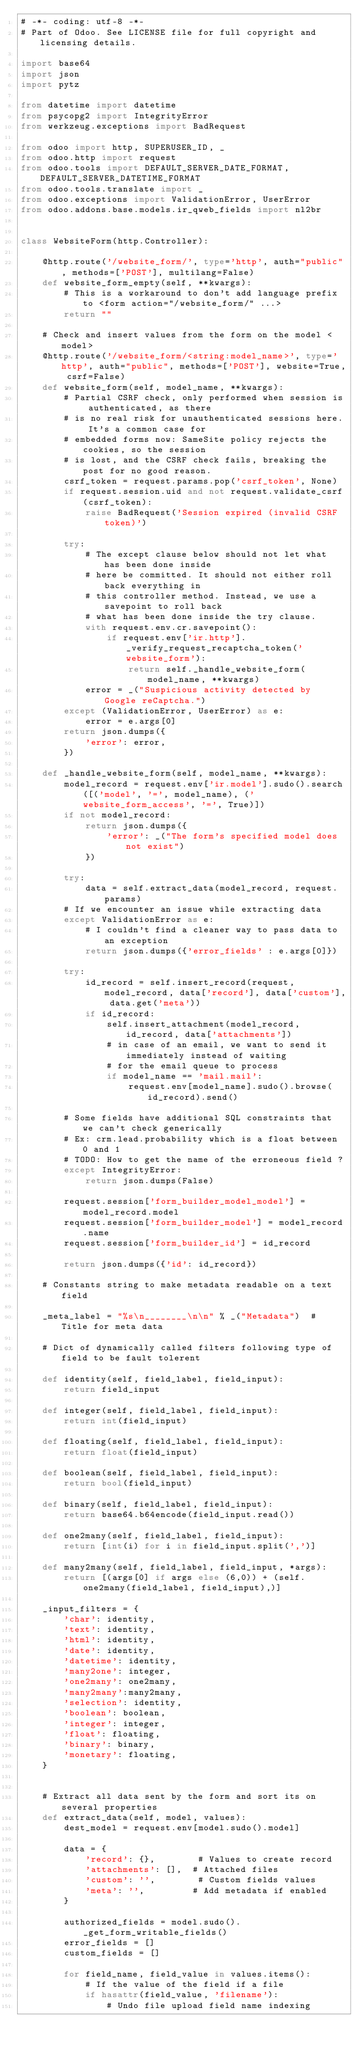<code> <loc_0><loc_0><loc_500><loc_500><_Python_># -*- coding: utf-8 -*-
# Part of Odoo. See LICENSE file for full copyright and licensing details.

import base64
import json
import pytz

from datetime import datetime
from psycopg2 import IntegrityError
from werkzeug.exceptions import BadRequest

from odoo import http, SUPERUSER_ID, _
from odoo.http import request
from odoo.tools import DEFAULT_SERVER_DATE_FORMAT, DEFAULT_SERVER_DATETIME_FORMAT
from odoo.tools.translate import _
from odoo.exceptions import ValidationError, UserError
from odoo.addons.base.models.ir_qweb_fields import nl2br


class WebsiteForm(http.Controller):

    @http.route('/website_form/', type='http', auth="public", methods=['POST'], multilang=False)
    def website_form_empty(self, **kwargs):
        # This is a workaround to don't add language prefix to <form action="/website_form/" ...>
        return ""

    # Check and insert values from the form on the model <model>
    @http.route('/website_form/<string:model_name>', type='http', auth="public", methods=['POST'], website=True, csrf=False)
    def website_form(self, model_name, **kwargs):
        # Partial CSRF check, only performed when session is authenticated, as there
        # is no real risk for unauthenticated sessions here. It's a common case for
        # embedded forms now: SameSite policy rejects the cookies, so the session
        # is lost, and the CSRF check fails, breaking the post for no good reason.
        csrf_token = request.params.pop('csrf_token', None)
        if request.session.uid and not request.validate_csrf(csrf_token):
            raise BadRequest('Session expired (invalid CSRF token)')

        try:
            # The except clause below should not let what has been done inside
            # here be committed. It should not either roll back everything in
            # this controller method. Instead, we use a savepoint to roll back
            # what has been done inside the try clause.
            with request.env.cr.savepoint():
                if request.env['ir.http']._verify_request_recaptcha_token('website_form'):
                    return self._handle_website_form(model_name, **kwargs)
            error = _("Suspicious activity detected by Google reCaptcha.")
        except (ValidationError, UserError) as e:
            error = e.args[0]
        return json.dumps({
            'error': error,
        })

    def _handle_website_form(self, model_name, **kwargs):
        model_record = request.env['ir.model'].sudo().search([('model', '=', model_name), ('website_form_access', '=', True)])
        if not model_record:
            return json.dumps({
                'error': _("The form's specified model does not exist")
            })

        try:
            data = self.extract_data(model_record, request.params)
        # If we encounter an issue while extracting data
        except ValidationError as e:
            # I couldn't find a cleaner way to pass data to an exception
            return json.dumps({'error_fields' : e.args[0]})

        try:
            id_record = self.insert_record(request, model_record, data['record'], data['custom'], data.get('meta'))
            if id_record:
                self.insert_attachment(model_record, id_record, data['attachments'])
                # in case of an email, we want to send it immediately instead of waiting
                # for the email queue to process
                if model_name == 'mail.mail':
                    request.env[model_name].sudo().browse(id_record).send()

        # Some fields have additional SQL constraints that we can't check generically
        # Ex: crm.lead.probability which is a float between 0 and 1
        # TODO: How to get the name of the erroneous field ?
        except IntegrityError:
            return json.dumps(False)

        request.session['form_builder_model_model'] = model_record.model
        request.session['form_builder_model'] = model_record.name
        request.session['form_builder_id'] = id_record

        return json.dumps({'id': id_record})

    # Constants string to make metadata readable on a text field

    _meta_label = "%s\n________\n\n" % _("Metadata")  # Title for meta data

    # Dict of dynamically called filters following type of field to be fault tolerent

    def identity(self, field_label, field_input):
        return field_input

    def integer(self, field_label, field_input):
        return int(field_input)

    def floating(self, field_label, field_input):
        return float(field_input)

    def boolean(self, field_label, field_input):
        return bool(field_input)

    def binary(self, field_label, field_input):
        return base64.b64encode(field_input.read())

    def one2many(self, field_label, field_input):
        return [int(i) for i in field_input.split(',')]

    def many2many(self, field_label, field_input, *args):
        return [(args[0] if args else (6,0)) + (self.one2many(field_label, field_input),)]

    _input_filters = {
        'char': identity,
        'text': identity,
        'html': identity,
        'date': identity,
        'datetime': identity,
        'many2one': integer,
        'one2many': one2many,
        'many2many':many2many,
        'selection': identity,
        'boolean': boolean,
        'integer': integer,
        'float': floating,
        'binary': binary,
        'monetary': floating,
    }


    # Extract all data sent by the form and sort its on several properties
    def extract_data(self, model, values):
        dest_model = request.env[model.sudo().model]

        data = {
            'record': {},        # Values to create record
            'attachments': [],  # Attached files
            'custom': '',        # Custom fields values
            'meta': '',         # Add metadata if enabled
        }

        authorized_fields = model.sudo()._get_form_writable_fields()
        error_fields = []
        custom_fields = []

        for field_name, field_value in values.items():
            # If the value of the field if a file
            if hasattr(field_value, 'filename'):
                # Undo file upload field name indexing</code> 